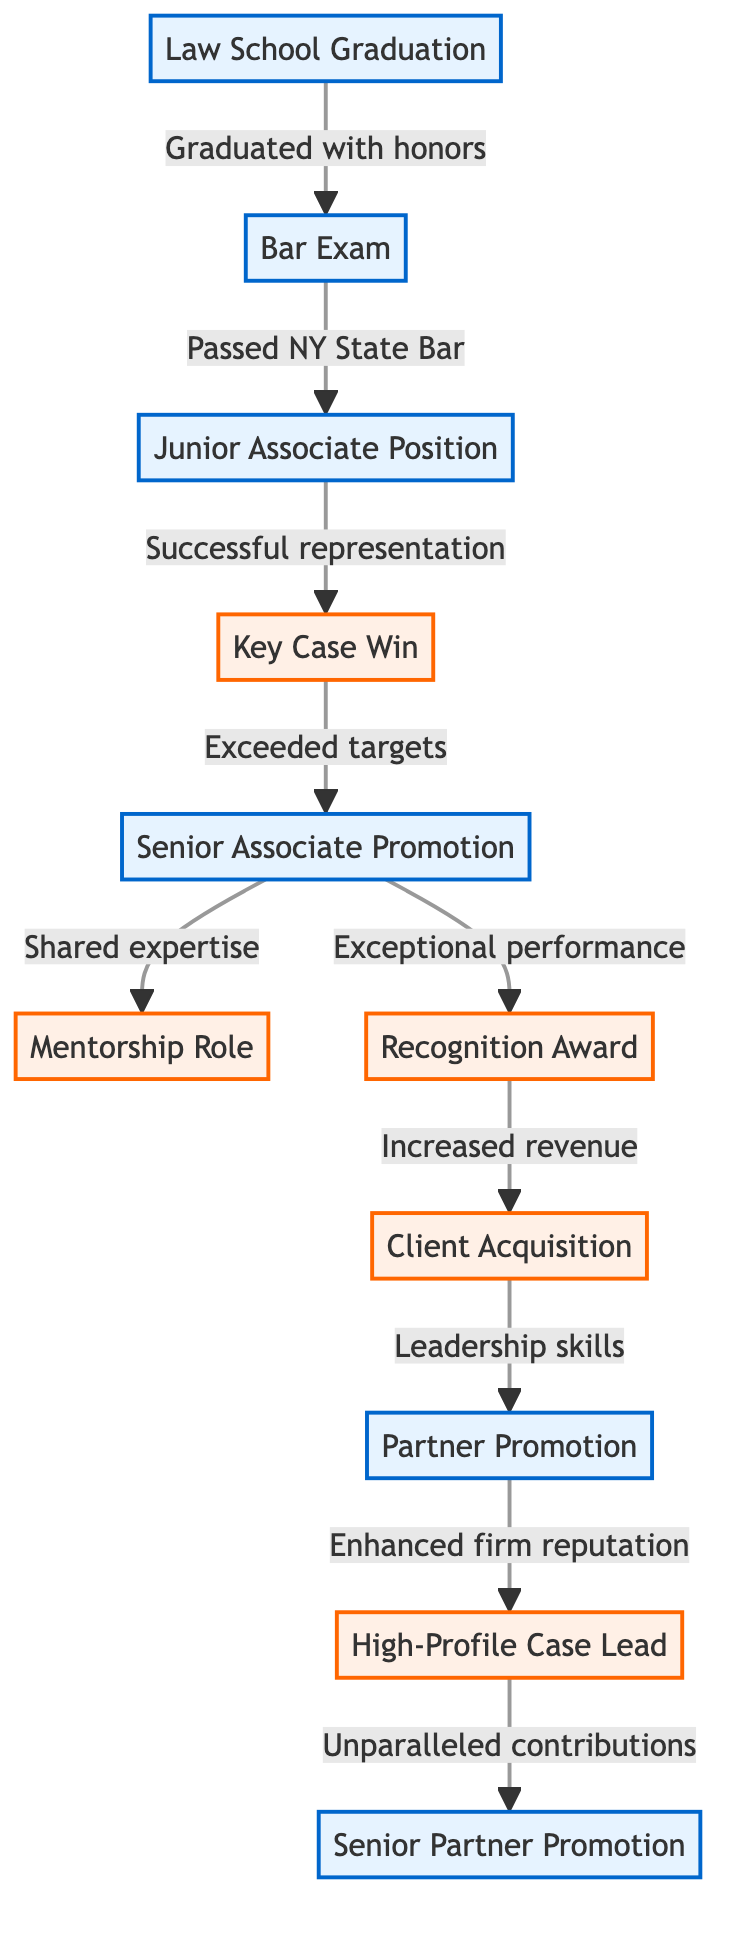What is the first milestone in the career progression? The first node in the diagram represents "Law School Graduation," which is identified as the starting point of the career path.
Answer: Law School Graduation How many nodes are there in the diagram? By counting the elements in the nodes list, we see there are 11 distinct nodes representing career milestones and achievements.
Answer: 11 What follows the Key Case Win? The directed edge from the "Key Case Win" node points to the "Senior Associate Promotion" node, indicating that the promotion follows the successful case win.
Answer: Senior Associate Promotion Which award is achieved after exceptional performance? The connection from the "Senior Associate Promotion" node to the "Recognition Award" node shows that this award is received after achieving exceptional performance as a Senior Associate.
Answer: Recognition Award What key achievement leads to acquiring a new client? The diagram indicates that the "Recognition Award" is linked to "Client Acquisition," suggesting that this award is a significant factor leading to securing new clients.
Answer: Client Acquisition What position is achieved after leading a high-profile case? The flow from the "High-Profile Case Lead" node leads to the "Senior Partner Promotion" node, showing that leadership in a high-profile case results in that promotion.
Answer: Senior Partner Promotion How many edges connect to the Partner Promotion? By examining the edges connected to the "Partner Promotion" node, we find that there is one edge leading into it from "Client Acquisition," indicating it is the only direct connection.
Answer: 1 Which milestone represents a major career achievement? The "Senior Partner Promotion" node is highlighted as a significant milestone, marked as the culmination of a successful career trajectory and contributions made to the firm.
Answer: Senior Partner Promotion What step is required to move from Junior Associate Position to Key Case Win? The directed edge shows that "successful representation" is the crucial action that transitions an individual from the "Junior Associate Position" to achieving a "Key Case Win."
Answer: Successful representation 